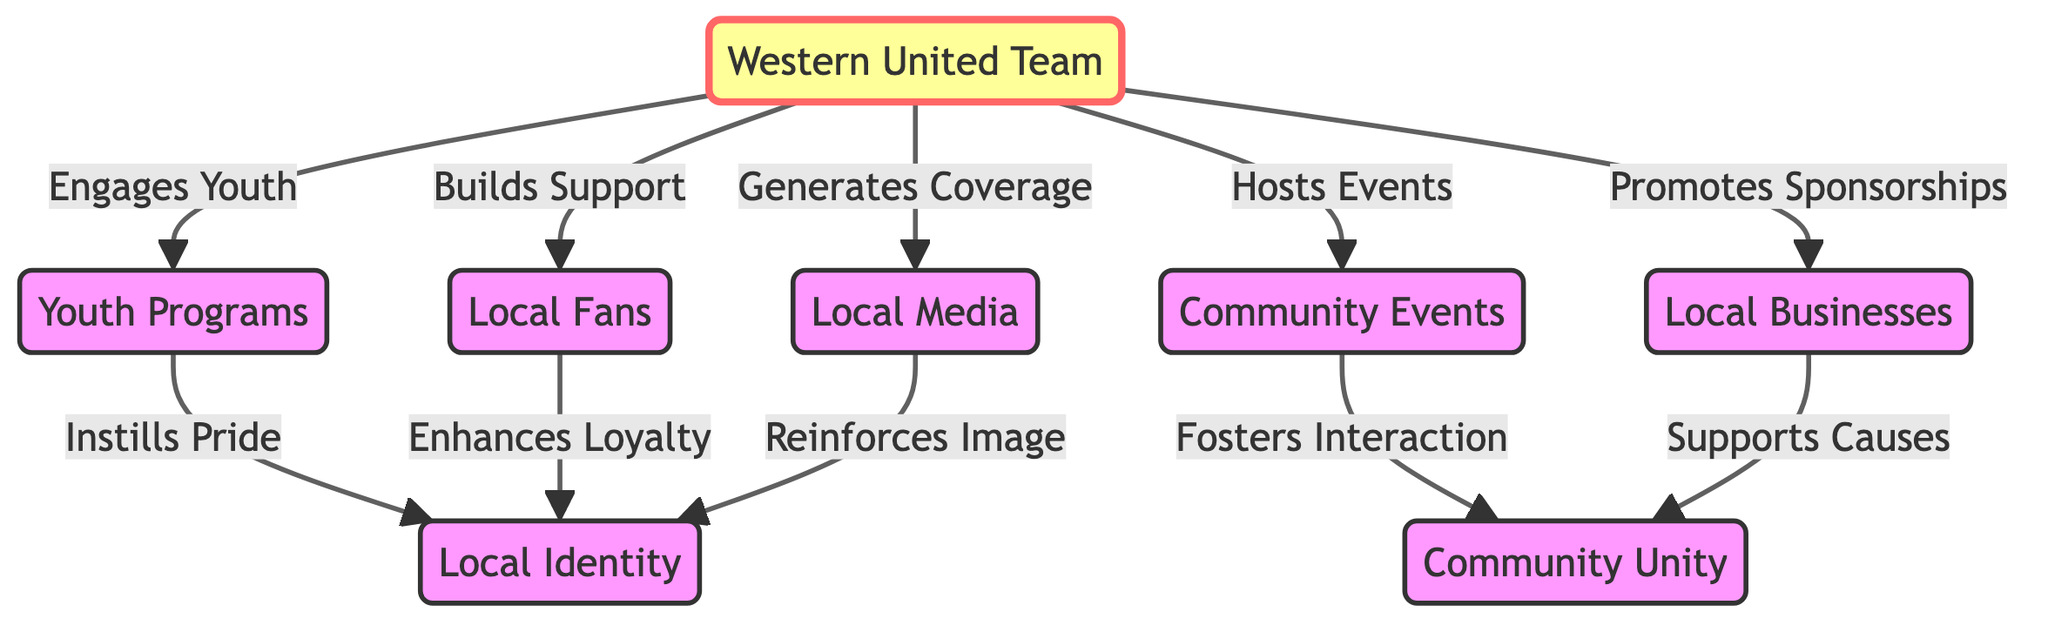What is the central node in the diagram? The central node in the diagram is Western United Team, which is emphasized and shows its primary role in the community.
Answer: Western United Team How many edges are connected to the Local Fans node? From the diagram, Local Fans is connected to one edge that goes out to Local Identity, indicating its relationship with enhancing loyalty.
Answer: 1 Which node is connected to the Community Events node? The Community Events node connects to Community Unity, indicating that fostering interaction leads to increased community unity.
Answer: Community Unity What effect does Western United have on Local Businesses? Western United promotes sponsorships to Local Businesses, indicating that this relationship is primarily about support.
Answer: Promotes Sponsorships How does Youth Programs influence Local Identity? Youth Programs instills pride in the local community, which directly contributes to a stronger sense of local identity.
Answer: Instills Pride What is the relationship between Local Businesses and Community Unity? Local Businesses support causes related to Community Unity, showing their role in enhancing community ties.
Answer: Supports Causes How many nodes are connected to the Western United Team? The Western United Team connects to five nodes: Local Fans, Youth Programs, Community Events, Local Businesses, and Local Media.
Answer: 5 Which node reinforces the image of Local Identity? Local Media reinforces the image of Local Identity, indicating its role in shaping community perceptions.
Answer: Local Media What connects Local Fans to Local Identity? The connection between Local Fans and Local Identity is described as enhancing loyalty, indicating the role of fan engagement.
Answer: Enhances Loyalty 